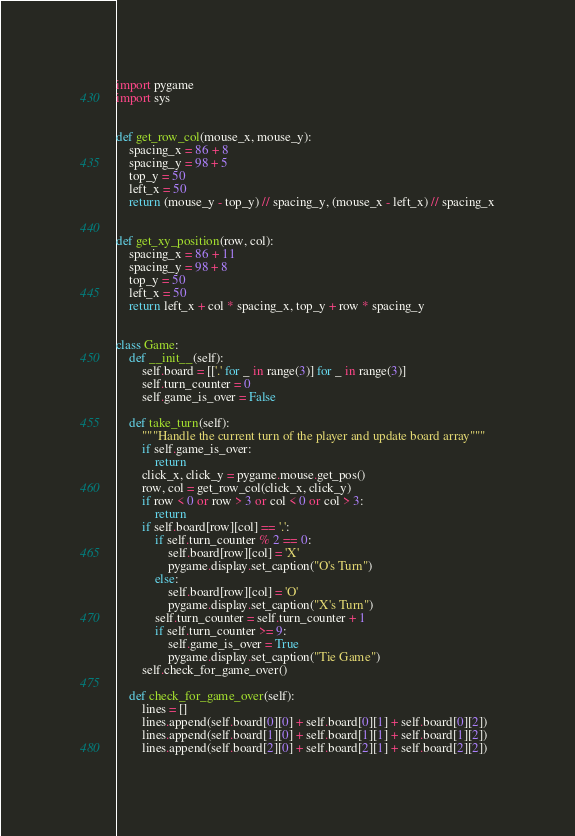<code> <loc_0><loc_0><loc_500><loc_500><_Python_>import pygame
import sys


def get_row_col(mouse_x, mouse_y):
    spacing_x = 86 + 8
    spacing_y = 98 + 5
    top_y = 50
    left_x = 50
    return (mouse_y - top_y) // spacing_y, (mouse_x - left_x) // spacing_x


def get_xy_position(row, col):
    spacing_x = 86 + 11
    spacing_y = 98 + 8
    top_y = 50
    left_x = 50
    return left_x + col * spacing_x, top_y + row * spacing_y


class Game:
    def __init__(self):
        self.board = [['.' for _ in range(3)] for _ in range(3)]
        self.turn_counter = 0
        self.game_is_over = False

    def take_turn(self):
        """Handle the current turn of the player and update board array"""
        if self.game_is_over:
            return
        click_x, click_y = pygame.mouse.get_pos()
        row, col = get_row_col(click_x, click_y)
        if row < 0 or row > 3 or col < 0 or col > 3:
            return
        if self.board[row][col] == '.':
            if self.turn_counter % 2 == 0:
                self.board[row][col] = 'X'
                pygame.display.set_caption("O's Turn")
            else:
                self.board[row][col] = 'O'
                pygame.display.set_caption("X's Turn")
            self.turn_counter = self.turn_counter + 1
            if self.turn_counter >= 9:
                self.game_is_over = True
                pygame.display.set_caption("Tie Game")
        self.check_for_game_over()

    def check_for_game_over(self):
        lines = []
        lines.append(self.board[0][0] + self.board[0][1] + self.board[0][2])
        lines.append(self.board[1][0] + self.board[1][1] + self.board[1][2])
        lines.append(self.board[2][0] + self.board[2][1] + self.board[2][2])</code> 